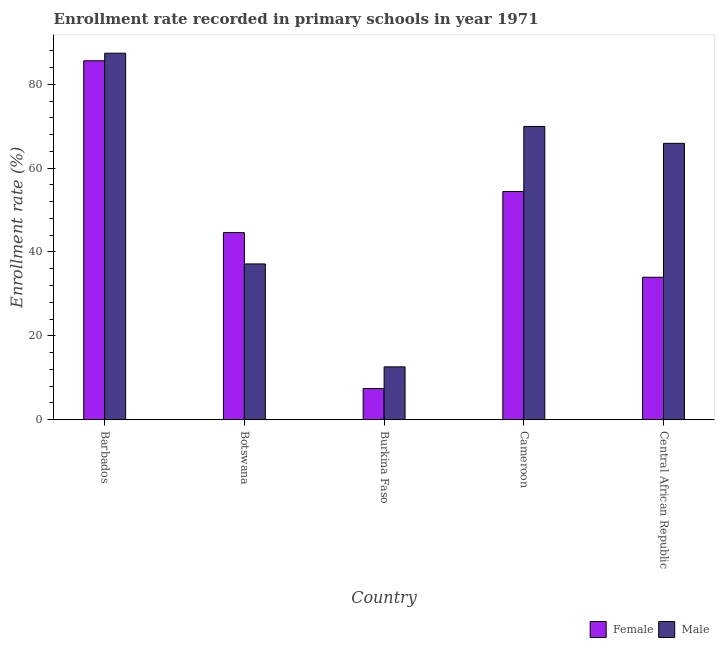How many different coloured bars are there?
Make the answer very short. 2. Are the number of bars on each tick of the X-axis equal?
Make the answer very short. Yes. How many bars are there on the 5th tick from the left?
Offer a very short reply. 2. How many bars are there on the 3rd tick from the right?
Your response must be concise. 2. What is the label of the 2nd group of bars from the left?
Your response must be concise. Botswana. In how many cases, is the number of bars for a given country not equal to the number of legend labels?
Provide a succinct answer. 0. What is the enrollment rate of male students in Botswana?
Your response must be concise. 37.15. Across all countries, what is the maximum enrollment rate of male students?
Your answer should be very brief. 87.41. Across all countries, what is the minimum enrollment rate of female students?
Your answer should be compact. 7.43. In which country was the enrollment rate of female students maximum?
Your response must be concise. Barbados. In which country was the enrollment rate of female students minimum?
Offer a very short reply. Burkina Faso. What is the total enrollment rate of female students in the graph?
Provide a short and direct response. 226.06. What is the difference between the enrollment rate of male students in Barbados and that in Burkina Faso?
Your response must be concise. 74.81. What is the difference between the enrollment rate of male students in Burkina Faso and the enrollment rate of female students in Central African Republic?
Provide a short and direct response. -21.37. What is the average enrollment rate of female students per country?
Your response must be concise. 45.21. What is the difference between the enrollment rate of male students and enrollment rate of female students in Cameroon?
Offer a very short reply. 15.51. What is the ratio of the enrollment rate of female students in Botswana to that in Burkina Faso?
Your answer should be compact. 6.01. Is the enrollment rate of female students in Botswana less than that in Burkina Faso?
Your answer should be very brief. No. Is the difference between the enrollment rate of male students in Barbados and Botswana greater than the difference between the enrollment rate of female students in Barbados and Botswana?
Give a very brief answer. Yes. What is the difference between the highest and the second highest enrollment rate of female students?
Your answer should be compact. 31.17. What is the difference between the highest and the lowest enrollment rate of female students?
Offer a very short reply. 78.17. Is the sum of the enrollment rate of female students in Botswana and Cameroon greater than the maximum enrollment rate of male students across all countries?
Offer a very short reply. Yes. What does the 1st bar from the right in Burkina Faso represents?
Keep it short and to the point. Male. How many countries are there in the graph?
Offer a very short reply. 5. Does the graph contain any zero values?
Your response must be concise. No. Does the graph contain grids?
Provide a succinct answer. No. Where does the legend appear in the graph?
Your answer should be very brief. Bottom right. What is the title of the graph?
Your answer should be very brief. Enrollment rate recorded in primary schools in year 1971. What is the label or title of the Y-axis?
Your response must be concise. Enrollment rate (%). What is the Enrollment rate (%) of Female in Barbados?
Your answer should be compact. 85.6. What is the Enrollment rate (%) of Male in Barbados?
Give a very brief answer. 87.41. What is the Enrollment rate (%) in Female in Botswana?
Ensure brevity in your answer.  44.63. What is the Enrollment rate (%) in Male in Botswana?
Make the answer very short. 37.15. What is the Enrollment rate (%) of Female in Burkina Faso?
Ensure brevity in your answer.  7.43. What is the Enrollment rate (%) in Male in Burkina Faso?
Provide a succinct answer. 12.6. What is the Enrollment rate (%) in Female in Cameroon?
Your answer should be compact. 54.43. What is the Enrollment rate (%) in Male in Cameroon?
Your response must be concise. 69.94. What is the Enrollment rate (%) in Female in Central African Republic?
Ensure brevity in your answer.  33.97. What is the Enrollment rate (%) in Male in Central African Republic?
Provide a succinct answer. 65.91. Across all countries, what is the maximum Enrollment rate (%) of Female?
Your answer should be compact. 85.6. Across all countries, what is the maximum Enrollment rate (%) of Male?
Give a very brief answer. 87.41. Across all countries, what is the minimum Enrollment rate (%) in Female?
Offer a very short reply. 7.43. Across all countries, what is the minimum Enrollment rate (%) of Male?
Offer a terse response. 12.6. What is the total Enrollment rate (%) of Female in the graph?
Keep it short and to the point. 226.06. What is the total Enrollment rate (%) in Male in the graph?
Ensure brevity in your answer.  273.02. What is the difference between the Enrollment rate (%) in Female in Barbados and that in Botswana?
Make the answer very short. 40.97. What is the difference between the Enrollment rate (%) in Male in Barbados and that in Botswana?
Keep it short and to the point. 50.26. What is the difference between the Enrollment rate (%) of Female in Barbados and that in Burkina Faso?
Provide a short and direct response. 78.17. What is the difference between the Enrollment rate (%) in Male in Barbados and that in Burkina Faso?
Offer a very short reply. 74.81. What is the difference between the Enrollment rate (%) in Female in Barbados and that in Cameroon?
Give a very brief answer. 31.17. What is the difference between the Enrollment rate (%) of Male in Barbados and that in Cameroon?
Offer a very short reply. 17.47. What is the difference between the Enrollment rate (%) in Female in Barbados and that in Central African Republic?
Your answer should be compact. 51.63. What is the difference between the Enrollment rate (%) of Male in Barbados and that in Central African Republic?
Give a very brief answer. 21.5. What is the difference between the Enrollment rate (%) in Female in Botswana and that in Burkina Faso?
Provide a short and direct response. 37.19. What is the difference between the Enrollment rate (%) in Male in Botswana and that in Burkina Faso?
Ensure brevity in your answer.  24.55. What is the difference between the Enrollment rate (%) of Female in Botswana and that in Cameroon?
Ensure brevity in your answer.  -9.8. What is the difference between the Enrollment rate (%) of Male in Botswana and that in Cameroon?
Your response must be concise. -32.79. What is the difference between the Enrollment rate (%) of Female in Botswana and that in Central African Republic?
Your response must be concise. 10.65. What is the difference between the Enrollment rate (%) of Male in Botswana and that in Central African Republic?
Your answer should be very brief. -28.76. What is the difference between the Enrollment rate (%) of Female in Burkina Faso and that in Cameroon?
Make the answer very short. -47. What is the difference between the Enrollment rate (%) in Male in Burkina Faso and that in Cameroon?
Ensure brevity in your answer.  -57.34. What is the difference between the Enrollment rate (%) in Female in Burkina Faso and that in Central African Republic?
Provide a succinct answer. -26.54. What is the difference between the Enrollment rate (%) in Male in Burkina Faso and that in Central African Republic?
Provide a short and direct response. -53.31. What is the difference between the Enrollment rate (%) in Female in Cameroon and that in Central African Republic?
Provide a succinct answer. 20.46. What is the difference between the Enrollment rate (%) of Male in Cameroon and that in Central African Republic?
Keep it short and to the point. 4.02. What is the difference between the Enrollment rate (%) in Female in Barbados and the Enrollment rate (%) in Male in Botswana?
Offer a very short reply. 48.45. What is the difference between the Enrollment rate (%) of Female in Barbados and the Enrollment rate (%) of Male in Burkina Faso?
Provide a short and direct response. 73. What is the difference between the Enrollment rate (%) of Female in Barbados and the Enrollment rate (%) of Male in Cameroon?
Provide a succinct answer. 15.66. What is the difference between the Enrollment rate (%) in Female in Barbados and the Enrollment rate (%) in Male in Central African Republic?
Offer a terse response. 19.69. What is the difference between the Enrollment rate (%) in Female in Botswana and the Enrollment rate (%) in Male in Burkina Faso?
Your answer should be compact. 32.03. What is the difference between the Enrollment rate (%) of Female in Botswana and the Enrollment rate (%) of Male in Cameroon?
Your answer should be very brief. -25.31. What is the difference between the Enrollment rate (%) in Female in Botswana and the Enrollment rate (%) in Male in Central African Republic?
Your answer should be compact. -21.29. What is the difference between the Enrollment rate (%) of Female in Burkina Faso and the Enrollment rate (%) of Male in Cameroon?
Your answer should be very brief. -62.51. What is the difference between the Enrollment rate (%) of Female in Burkina Faso and the Enrollment rate (%) of Male in Central African Republic?
Your answer should be very brief. -58.48. What is the difference between the Enrollment rate (%) in Female in Cameroon and the Enrollment rate (%) in Male in Central African Republic?
Keep it short and to the point. -11.49. What is the average Enrollment rate (%) in Female per country?
Offer a terse response. 45.21. What is the average Enrollment rate (%) in Male per country?
Provide a short and direct response. 54.6. What is the difference between the Enrollment rate (%) of Female and Enrollment rate (%) of Male in Barbados?
Provide a short and direct response. -1.81. What is the difference between the Enrollment rate (%) of Female and Enrollment rate (%) of Male in Botswana?
Offer a very short reply. 7.47. What is the difference between the Enrollment rate (%) of Female and Enrollment rate (%) of Male in Burkina Faso?
Offer a terse response. -5.17. What is the difference between the Enrollment rate (%) of Female and Enrollment rate (%) of Male in Cameroon?
Your answer should be compact. -15.51. What is the difference between the Enrollment rate (%) in Female and Enrollment rate (%) in Male in Central African Republic?
Offer a very short reply. -31.94. What is the ratio of the Enrollment rate (%) of Female in Barbados to that in Botswana?
Ensure brevity in your answer.  1.92. What is the ratio of the Enrollment rate (%) in Male in Barbados to that in Botswana?
Ensure brevity in your answer.  2.35. What is the ratio of the Enrollment rate (%) of Female in Barbados to that in Burkina Faso?
Provide a short and direct response. 11.52. What is the ratio of the Enrollment rate (%) of Male in Barbados to that in Burkina Faso?
Offer a very short reply. 6.94. What is the ratio of the Enrollment rate (%) in Female in Barbados to that in Cameroon?
Keep it short and to the point. 1.57. What is the ratio of the Enrollment rate (%) of Male in Barbados to that in Cameroon?
Offer a very short reply. 1.25. What is the ratio of the Enrollment rate (%) of Female in Barbados to that in Central African Republic?
Your answer should be compact. 2.52. What is the ratio of the Enrollment rate (%) of Male in Barbados to that in Central African Republic?
Offer a terse response. 1.33. What is the ratio of the Enrollment rate (%) in Female in Botswana to that in Burkina Faso?
Keep it short and to the point. 6. What is the ratio of the Enrollment rate (%) in Male in Botswana to that in Burkina Faso?
Your response must be concise. 2.95. What is the ratio of the Enrollment rate (%) of Female in Botswana to that in Cameroon?
Keep it short and to the point. 0.82. What is the ratio of the Enrollment rate (%) of Male in Botswana to that in Cameroon?
Ensure brevity in your answer.  0.53. What is the ratio of the Enrollment rate (%) in Female in Botswana to that in Central African Republic?
Offer a terse response. 1.31. What is the ratio of the Enrollment rate (%) of Male in Botswana to that in Central African Republic?
Give a very brief answer. 0.56. What is the ratio of the Enrollment rate (%) of Female in Burkina Faso to that in Cameroon?
Keep it short and to the point. 0.14. What is the ratio of the Enrollment rate (%) of Male in Burkina Faso to that in Cameroon?
Your answer should be compact. 0.18. What is the ratio of the Enrollment rate (%) in Female in Burkina Faso to that in Central African Republic?
Offer a very short reply. 0.22. What is the ratio of the Enrollment rate (%) in Male in Burkina Faso to that in Central African Republic?
Provide a short and direct response. 0.19. What is the ratio of the Enrollment rate (%) of Female in Cameroon to that in Central African Republic?
Provide a succinct answer. 1.6. What is the ratio of the Enrollment rate (%) of Male in Cameroon to that in Central African Republic?
Your answer should be very brief. 1.06. What is the difference between the highest and the second highest Enrollment rate (%) in Female?
Offer a terse response. 31.17. What is the difference between the highest and the second highest Enrollment rate (%) in Male?
Provide a short and direct response. 17.47. What is the difference between the highest and the lowest Enrollment rate (%) in Female?
Make the answer very short. 78.17. What is the difference between the highest and the lowest Enrollment rate (%) in Male?
Make the answer very short. 74.81. 